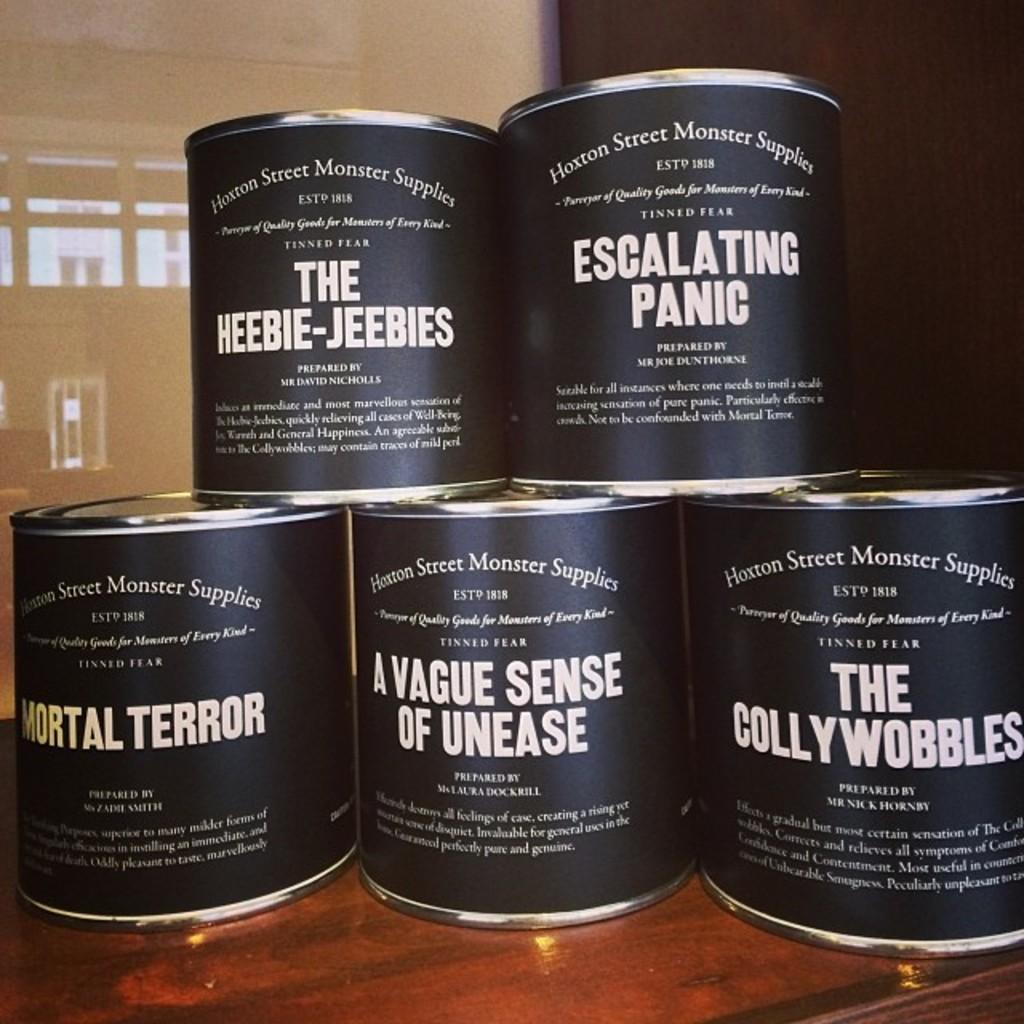<image>
Summarize the visual content of the image. A bunch of canned products made by Hoxton Street Monster Supplies are stack on top of each other. 